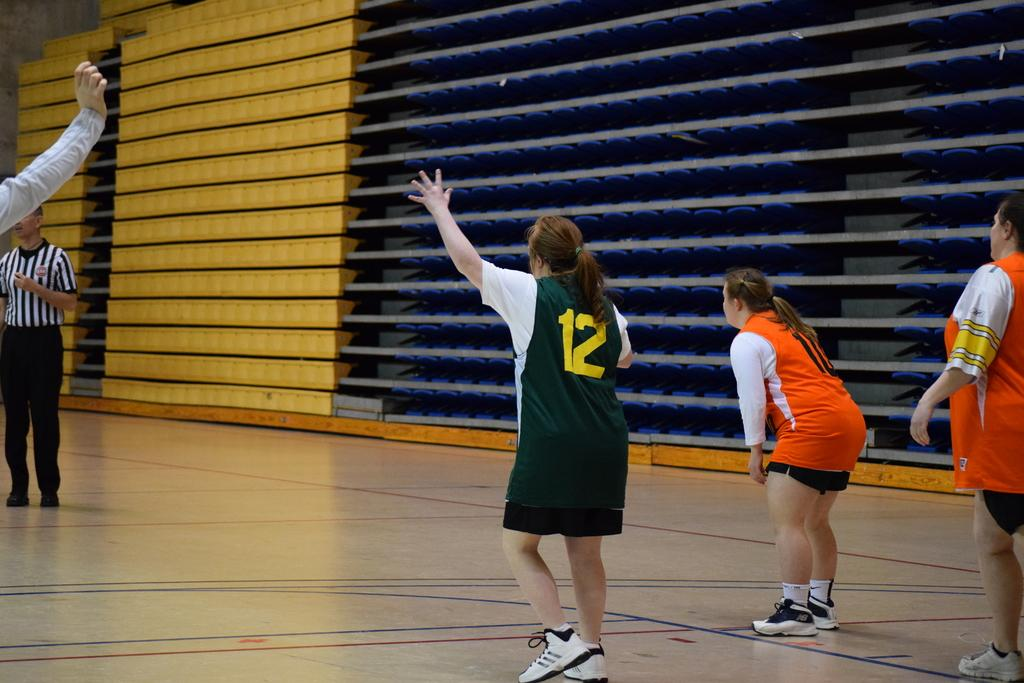Who or what is present in the image? There are people in the image. What can be seen beneath the people? The floor is visible in the image. What is located in the background of the image? There are racks in the background of the image. Can you tell me what type of dog is sitting next to the people in the image? There is no dog present in the image; only people are visible. 